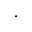<formula> <loc_0><loc_0><loc_500><loc_500>\cdot</formula> 